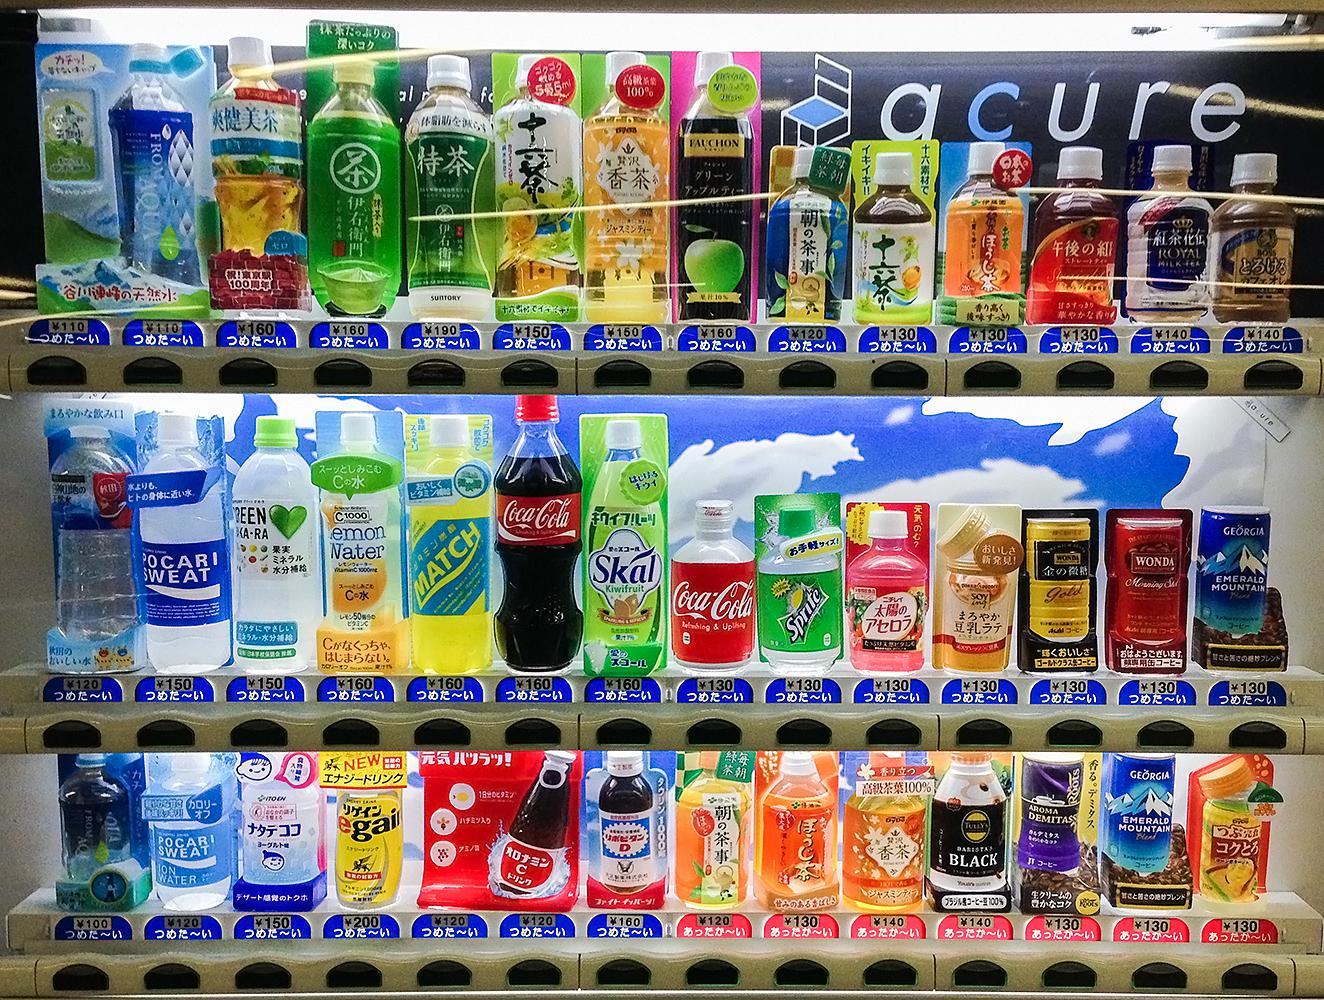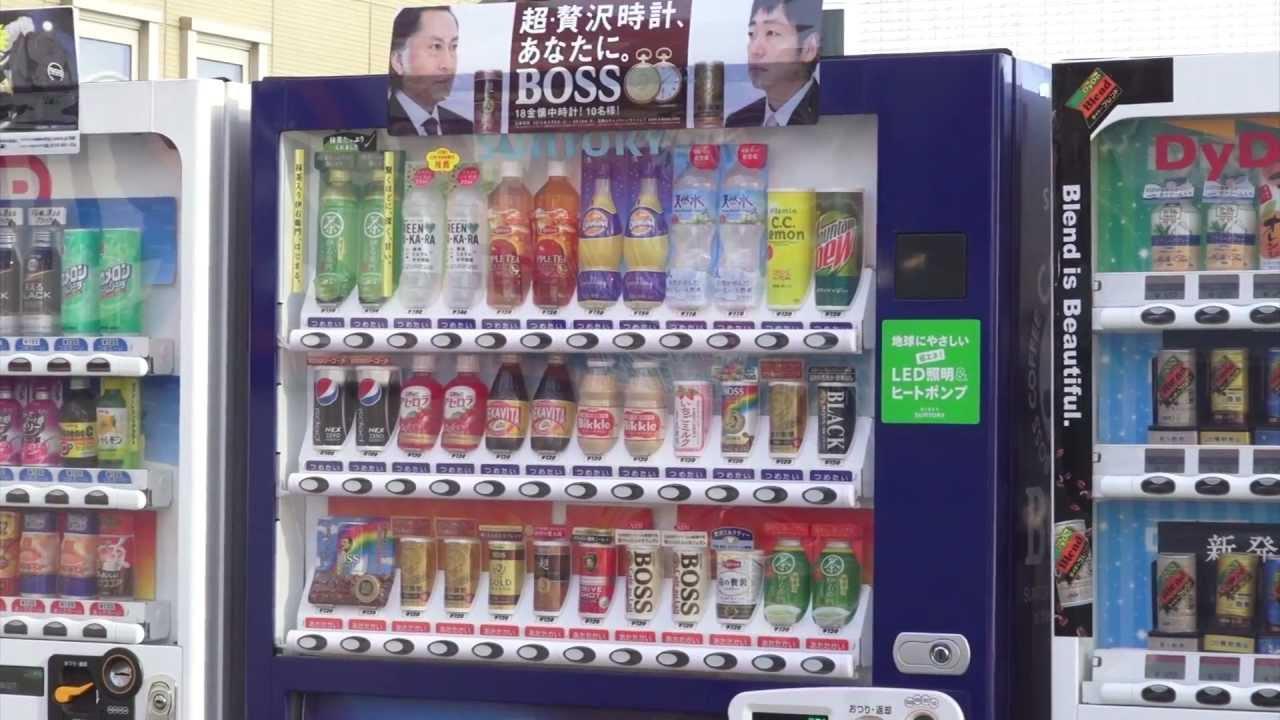The first image is the image on the left, the second image is the image on the right. Considering the images on both sides, is "There are no more than three vending machines in the image on the right." valid? Answer yes or no. Yes. The first image is the image on the left, the second image is the image on the right. Assess this claim about the two images: "One of the machines sitting amongst the others is blue.". Correct or not? Answer yes or no. Yes. The first image is the image on the left, the second image is the image on the right. Evaluate the accuracy of this statement regarding the images: "Each image shows a row of at least three vending machines.". Is it true? Answer yes or no. No. The first image is the image on the left, the second image is the image on the right. Evaluate the accuracy of this statement regarding the images: "An image focuses on a blue vending machine that dispenses some bottled items.". Is it true? Answer yes or no. Yes. 